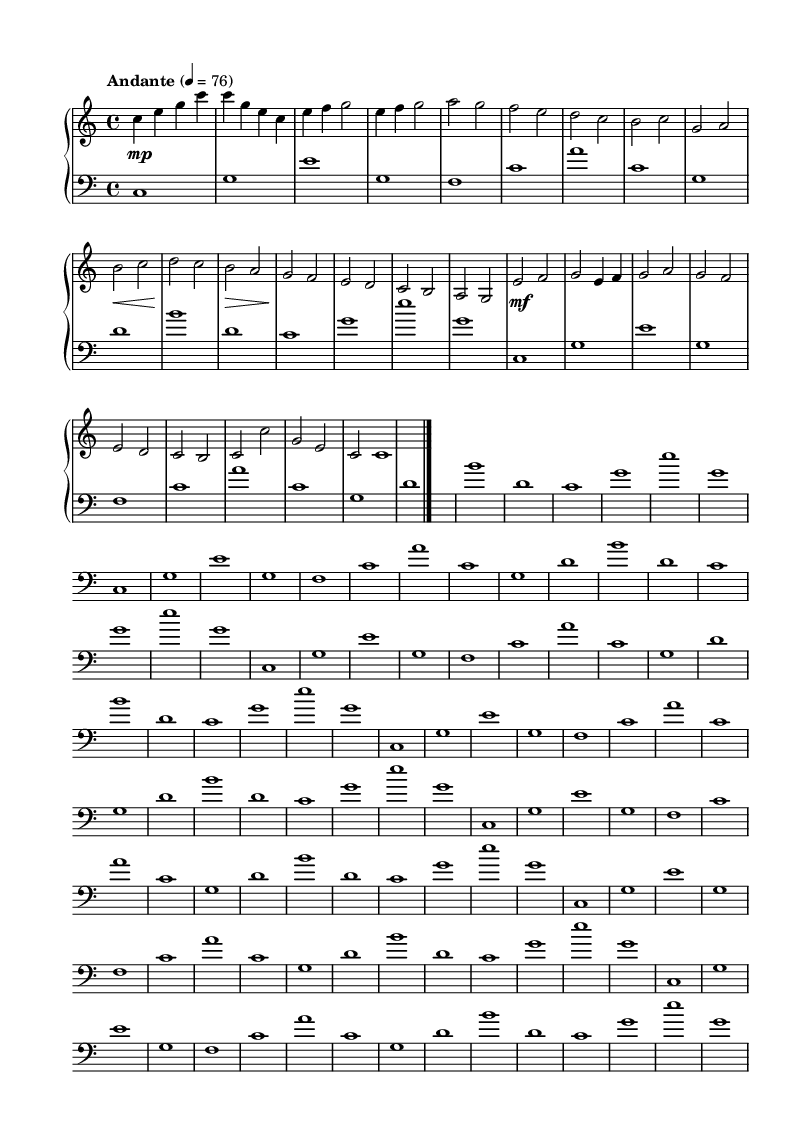What is the key signature of this music? The key signature is C major, as indicated by the absence of sharps or flats at the beginning of the staff.
Answer: C major What is the time signature of this music? The time signature is 4/4, which is shown at the beginning of the staff and indicates that there are four beats in each measure.
Answer: 4/4 What is the tempo marking given in this sheet music? The tempo marking is "Andante," which suggests a moderate pace, and it’s paired with the metronome marking of 76 beats per minute.
Answer: Andante How many sections are identified in the piece? The piece has three main sections labeled A, B, and C, along with an intro and a coda, making a total of five distinct parts.
Answer: Five What dynamic indications are present in the music? The music includes dynamic markings, such as "mp" for mezzo-piano, "mf" for mezzo-forte, and specific indications of crescendo and decrescendo (loud to soft).
Answer: mp, mf Which instruments are indicated in the score? The score features a piano, specifically separated into a treble and bass staff, indicating it is written for piano performance.
Answer: Piano What style of music does this sheet represent? The sheet music represents minimalist piano music, characterized by its repetitive structures and subtle variations, making it suitable for soundtracks in film contexts.
Answer: Minimalist 